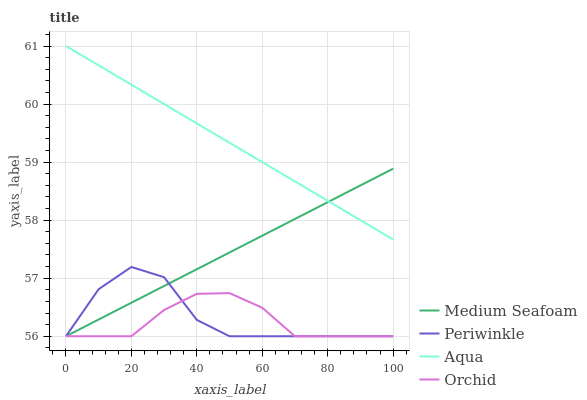Does Periwinkle have the minimum area under the curve?
Answer yes or no. No. Does Periwinkle have the maximum area under the curve?
Answer yes or no. No. Is Periwinkle the smoothest?
Answer yes or no. No. Is Medium Seafoam the roughest?
Answer yes or no. No. Does Periwinkle have the highest value?
Answer yes or no. No. Is Orchid less than Aqua?
Answer yes or no. Yes. Is Aqua greater than Periwinkle?
Answer yes or no. Yes. Does Orchid intersect Aqua?
Answer yes or no. No. 